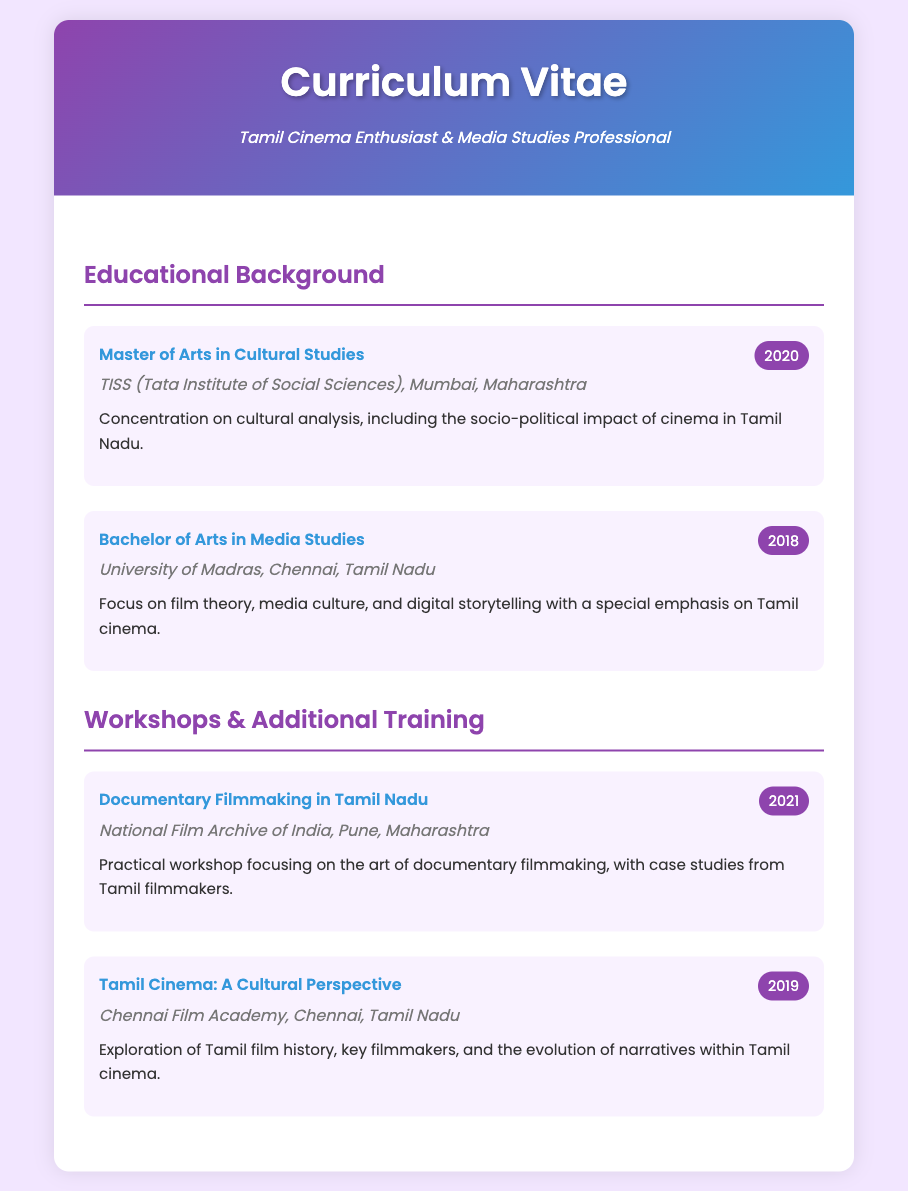what is the degree obtained in 2020? The educational background section details a Master's degree obtained in 2020, specifically in Cultural Studies.
Answer: Master of Arts in Cultural Studies what institution awarded the Bachelor of Arts in Media Studies? The institution listed for the Bachelor of Arts degree is the University of Madras.
Answer: University of Madras what is the focus area of the Master of Arts in Cultural Studies? The description under the 2020 degree explains the concentration on cultural analysis and cinema's socio-political impact.
Answer: socio-political impact of cinema in Tamil Nadu what workshop was organized by the National Film Archive of India? The document indicates a workshop in 2021 focused on documentary filmmaking held by the National Film Archive of India.
Answer: Documentary Filmmaking in Tamil Nadu how many years apart were the Bachelor and Master degrees obtained? The degrees were awarded in 2018 and 2020, respectively, indicating they are two years apart.
Answer: 2 years which workshop explored Tamil film history? The workshop titled "Tamil Cinema: A Cultural Perspective" specifically explored Tamil film history.
Answer: Tamil Cinema: A Cultural Perspective what year was the workshop "Tamil Cinema: A Cultural Perspective" conducted? The document specifies that this workshop took place in 2019.
Answer: 2019 what is the primary theme of the workshops listed? The descriptions indicate that the workshops mainly revolve around Tamil cinema and filmmaking.
Answer: Tamil cinema and filmmaking 